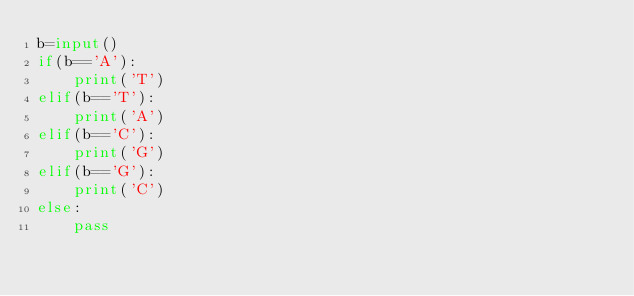<code> <loc_0><loc_0><loc_500><loc_500><_Python_>b=input()
if(b=='A'):
    print('T')
elif(b=='T'):
    print('A')
elif(b=='C'):
    print('G')
elif(b=='G'):
    print('C')
else:
    pass</code> 